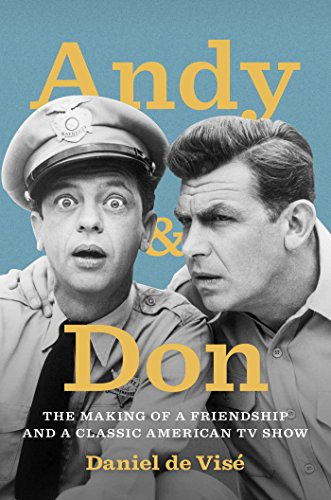Could you suggest who might enjoy reading this book? This book would appeal to fans of classic television, particularly those who hold a fondness for 'The Andy Griffith Show'. It would also attract readers interested in celebrity biographies, entertainment history, and the exploration of friendships in the television industry. 